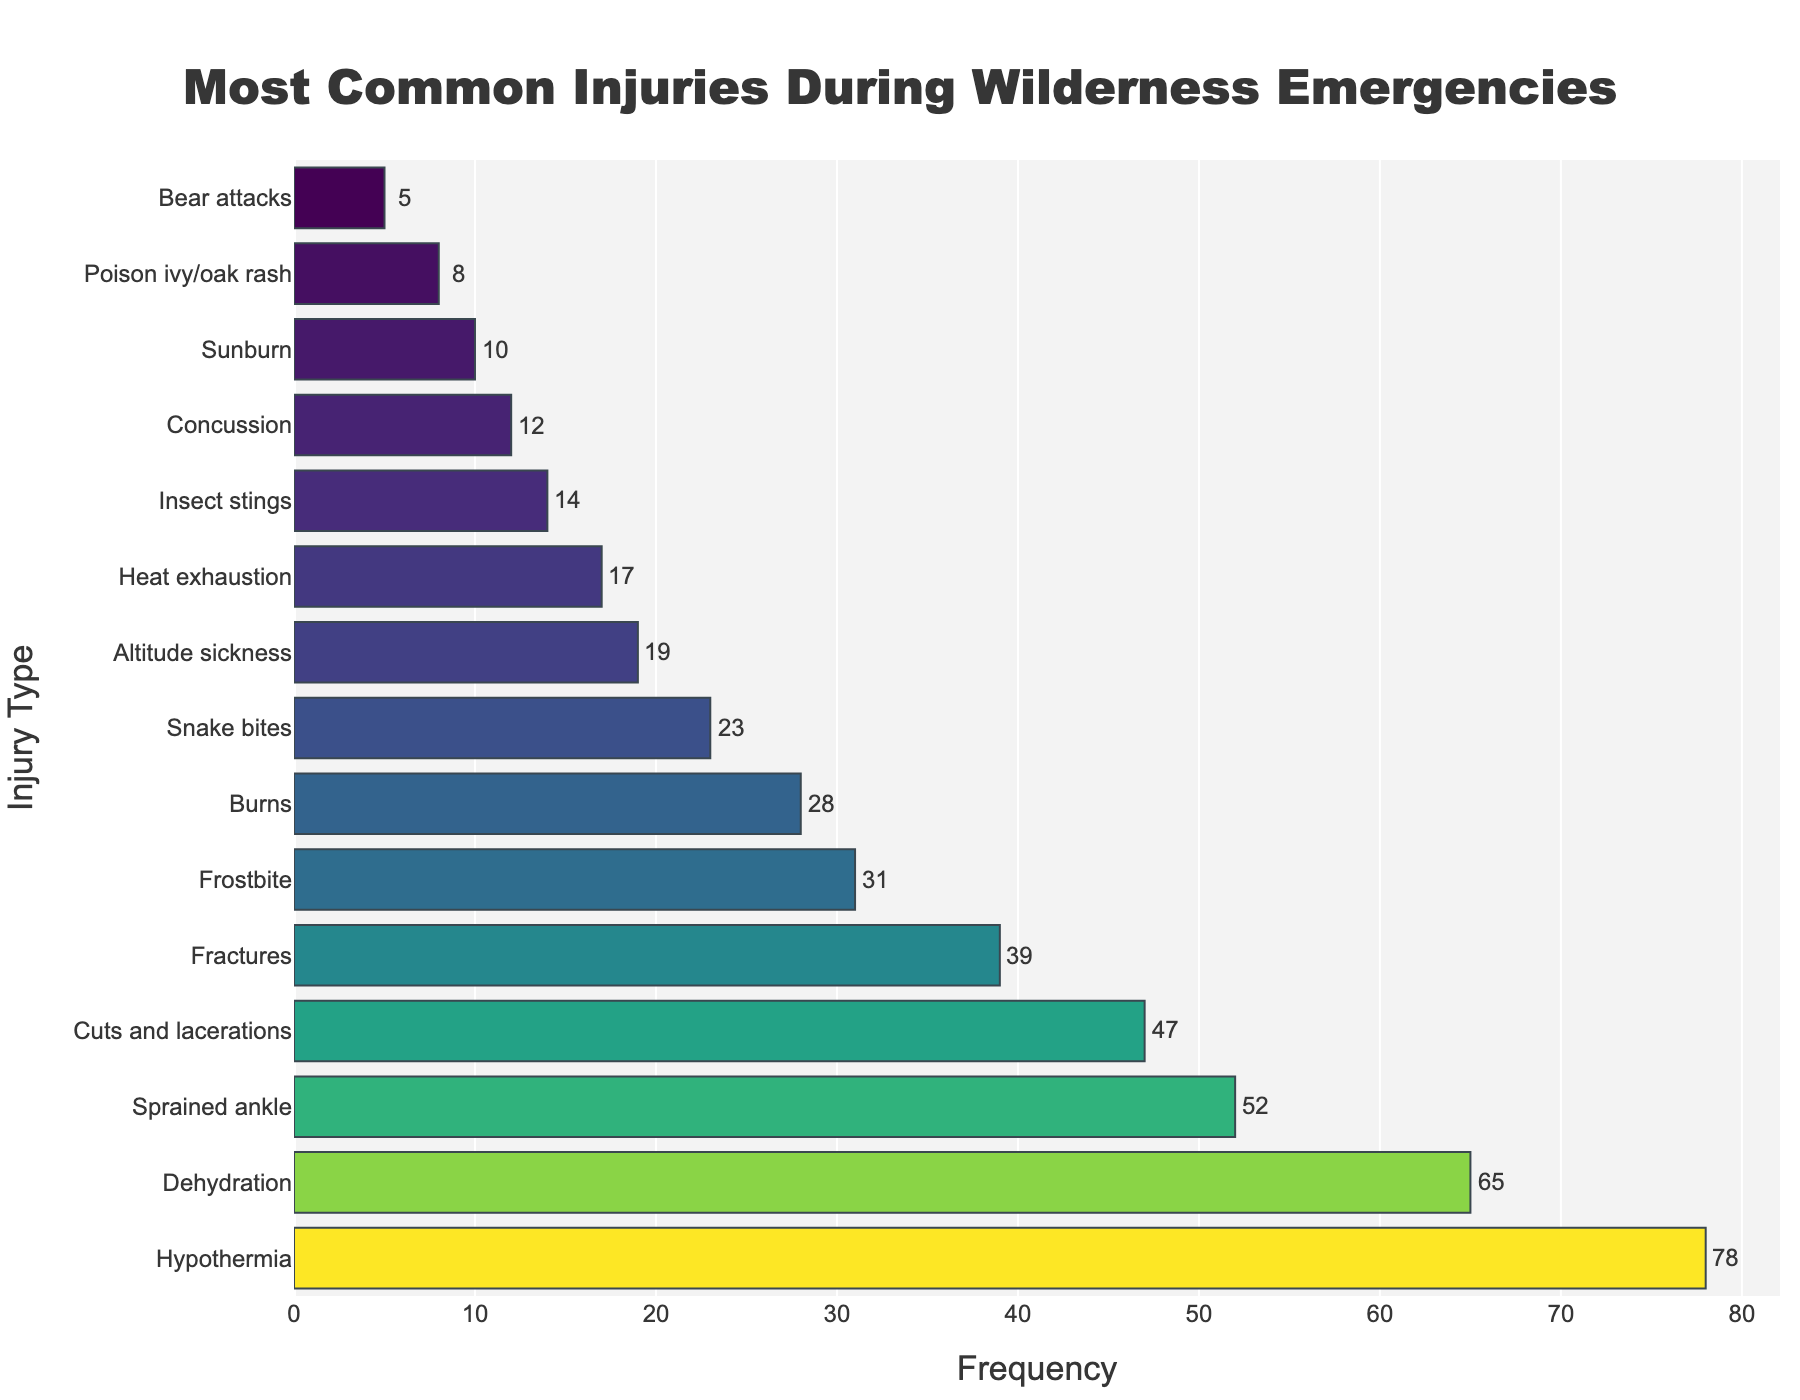Which injury is the most common during wilderness emergencies? To determine the most common injury, look at the bar with the highest frequency value.
Answer: Hypothermia By how much does the frequency of dehydration differ from that of hypothermia? Identify the frequencies of dehydration (65) and hypothermia (78), then subtract the frequency of dehydration from hypothermia: 78 - 65.
Answer: 13 What is the combined frequency of fractures and burns? Look up the frequencies of fractures (39) and burns (28), and then add them together: 39 + 28.
Answer: 67 Which injury type has the lowest frequency? Identify the bar with the lowest height, representing the lowest frequency value.
Answer: Bear attacks How many more cases of snake bites are there than altitude sickness? Find the frequencies of snake bites (23) and altitude sickness (19), then subtract the latter from the former: 23 - 19.
Answer: 4 Is the frequency of sunburn higher or lower than that of concussions? Compare the frequencies of sunburn (10) and concussion (12).
Answer: Lower Sum the frequencies of all injuries with a frequency over 50. Identify injuries with frequencies over 50: hypothermia (78), dehydration (65), and sprained ankle (52). Sum them: 78 + 65 + 52.
Answer: 195 Are there more incidents of bear attacks or poison ivy/oak rash? Compare the frequencies of bear attacks (5) and poison ivy/oak rash (8).
Answer: Poison ivy/oak rash Which injury types have a frequency under 20? Identify the injuries with frequencies less than 20: altitude sickness (19), heat exhaustion (17), insect stings (14), concussion (12), sunburn (10), poison ivy/oak rash (8), bear attacks (5).
Answer: Altitude sickness, heat exhaustion, insect stings, concussion, sunburn, poison ivy/oak rash, bear attacks What is the range of the frequencies shown? Subtract the smallest frequency (bear attacks: 5) from the largest (hypothermia: 78): 78 - 5.
Answer: 73 